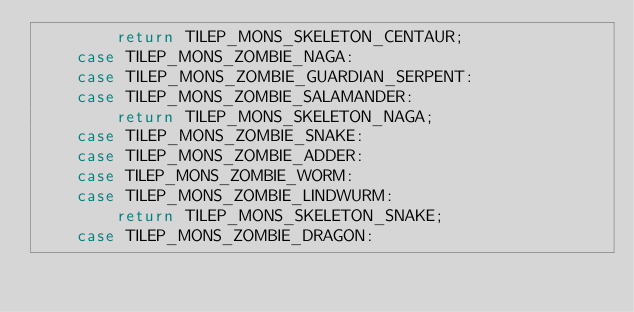Convert code to text. <code><loc_0><loc_0><loc_500><loc_500><_C++_>        return TILEP_MONS_SKELETON_CENTAUR;
    case TILEP_MONS_ZOMBIE_NAGA:
    case TILEP_MONS_ZOMBIE_GUARDIAN_SERPENT:
    case TILEP_MONS_ZOMBIE_SALAMANDER:
        return TILEP_MONS_SKELETON_NAGA;
    case TILEP_MONS_ZOMBIE_SNAKE:
    case TILEP_MONS_ZOMBIE_ADDER:
    case TILEP_MONS_ZOMBIE_WORM:
    case TILEP_MONS_ZOMBIE_LINDWURM:
        return TILEP_MONS_SKELETON_SNAKE;
    case TILEP_MONS_ZOMBIE_DRAGON:</code> 